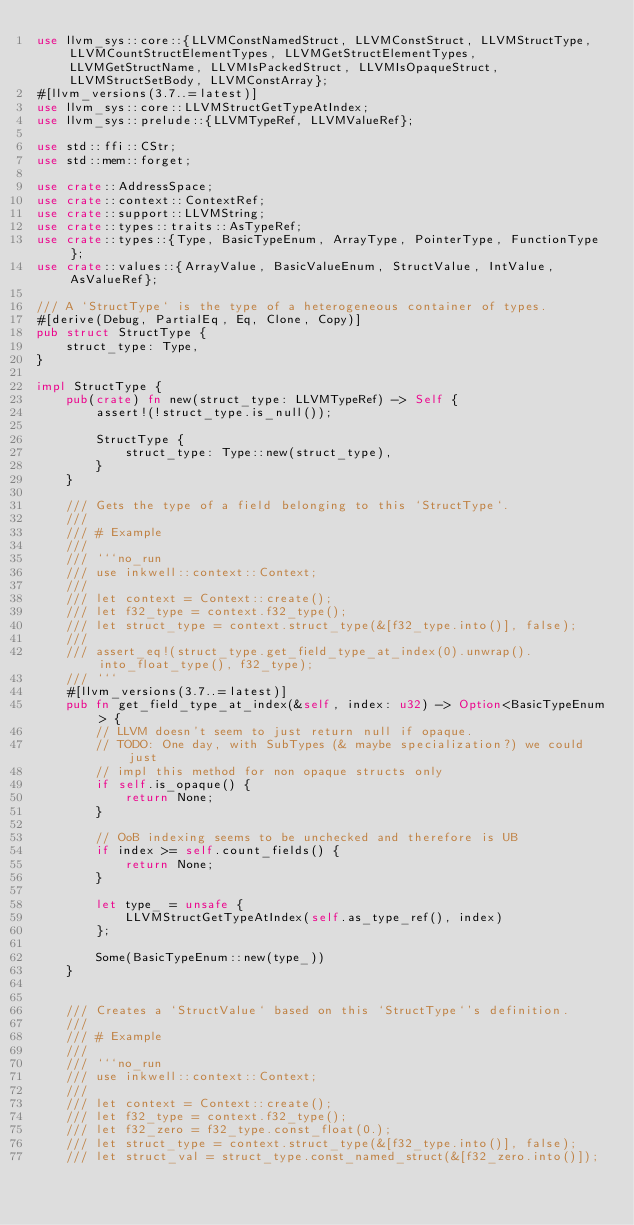<code> <loc_0><loc_0><loc_500><loc_500><_Rust_>use llvm_sys::core::{LLVMConstNamedStruct, LLVMConstStruct, LLVMStructType, LLVMCountStructElementTypes, LLVMGetStructElementTypes, LLVMGetStructName, LLVMIsPackedStruct, LLVMIsOpaqueStruct, LLVMStructSetBody, LLVMConstArray};
#[llvm_versions(3.7..=latest)]
use llvm_sys::core::LLVMStructGetTypeAtIndex;
use llvm_sys::prelude::{LLVMTypeRef, LLVMValueRef};

use std::ffi::CStr;
use std::mem::forget;

use crate::AddressSpace;
use crate::context::ContextRef;
use crate::support::LLVMString;
use crate::types::traits::AsTypeRef;
use crate::types::{Type, BasicTypeEnum, ArrayType, PointerType, FunctionType};
use crate::values::{ArrayValue, BasicValueEnum, StructValue, IntValue, AsValueRef};

/// A `StructType` is the type of a heterogeneous container of types.
#[derive(Debug, PartialEq, Eq, Clone, Copy)]
pub struct StructType {
    struct_type: Type,
}

impl StructType {
    pub(crate) fn new(struct_type: LLVMTypeRef) -> Self {
        assert!(!struct_type.is_null());

        StructType {
            struct_type: Type::new(struct_type),
        }
    }

    /// Gets the type of a field belonging to this `StructType`.
    ///
    /// # Example
    ///
    /// ```no_run
    /// use inkwell::context::Context;
    ///
    /// let context = Context::create();
    /// let f32_type = context.f32_type();
    /// let struct_type = context.struct_type(&[f32_type.into()], false);
    ///
    /// assert_eq!(struct_type.get_field_type_at_index(0).unwrap().into_float_type(), f32_type);
    /// ```
    #[llvm_versions(3.7..=latest)]
    pub fn get_field_type_at_index(&self, index: u32) -> Option<BasicTypeEnum> {
        // LLVM doesn't seem to just return null if opaque.
        // TODO: One day, with SubTypes (& maybe specialization?) we could just
        // impl this method for non opaque structs only
        if self.is_opaque() {
            return None;
        }

        // OoB indexing seems to be unchecked and therefore is UB
        if index >= self.count_fields() {
            return None;
        }

        let type_ = unsafe {
            LLVMStructGetTypeAtIndex(self.as_type_ref(), index)
        };

        Some(BasicTypeEnum::new(type_))
    }


    /// Creates a `StructValue` based on this `StructType`'s definition.
    ///
    /// # Example
    ///
    /// ```no_run
    /// use inkwell::context::Context;
    ///
    /// let context = Context::create();
    /// let f32_type = context.f32_type();
    /// let f32_zero = f32_type.const_float(0.);
    /// let struct_type = context.struct_type(&[f32_type.into()], false);
    /// let struct_val = struct_type.const_named_struct(&[f32_zero.into()]);</code> 